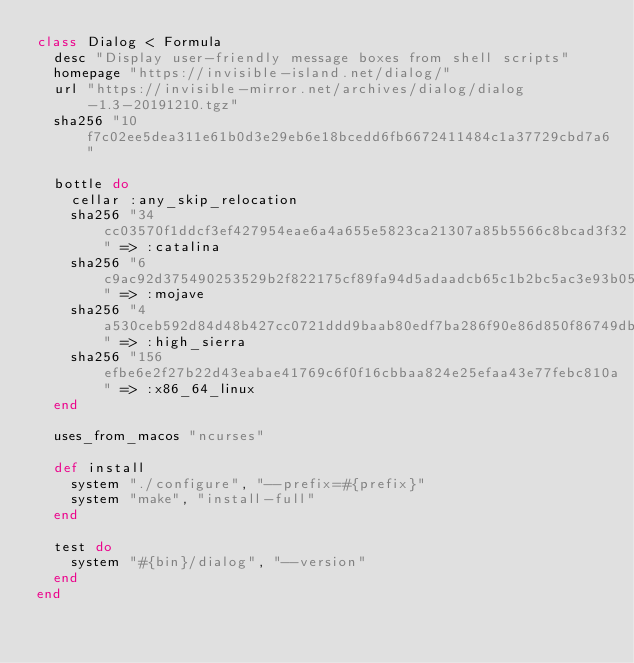<code> <loc_0><loc_0><loc_500><loc_500><_Ruby_>class Dialog < Formula
  desc "Display user-friendly message boxes from shell scripts"
  homepage "https://invisible-island.net/dialog/"
  url "https://invisible-mirror.net/archives/dialog/dialog-1.3-20191210.tgz"
  sha256 "10f7c02ee5dea311e61b0d3e29eb6e18bcedd6fb6672411484c1a37729cbd7a6"

  bottle do
    cellar :any_skip_relocation
    sha256 "34cc03570f1ddcf3ef427954eae6a4a655e5823ca21307a85b5566c8bcad3f32" => :catalina
    sha256 "6c9ac92d375490253529b2f822175cf89fa94d5adaadcb65c1b2bc5ac3e93b05" => :mojave
    sha256 "4a530ceb592d84d48b427cc0721ddd9baab80edf7ba286f90e86d850f86749db" => :high_sierra
    sha256 "156efbe6e2f27b22d43eabae41769c6f0f16cbbaa824e25efaa43e77febc810a" => :x86_64_linux
  end

  uses_from_macos "ncurses"

  def install
    system "./configure", "--prefix=#{prefix}"
    system "make", "install-full"
  end

  test do
    system "#{bin}/dialog", "--version"
  end
end
</code> 